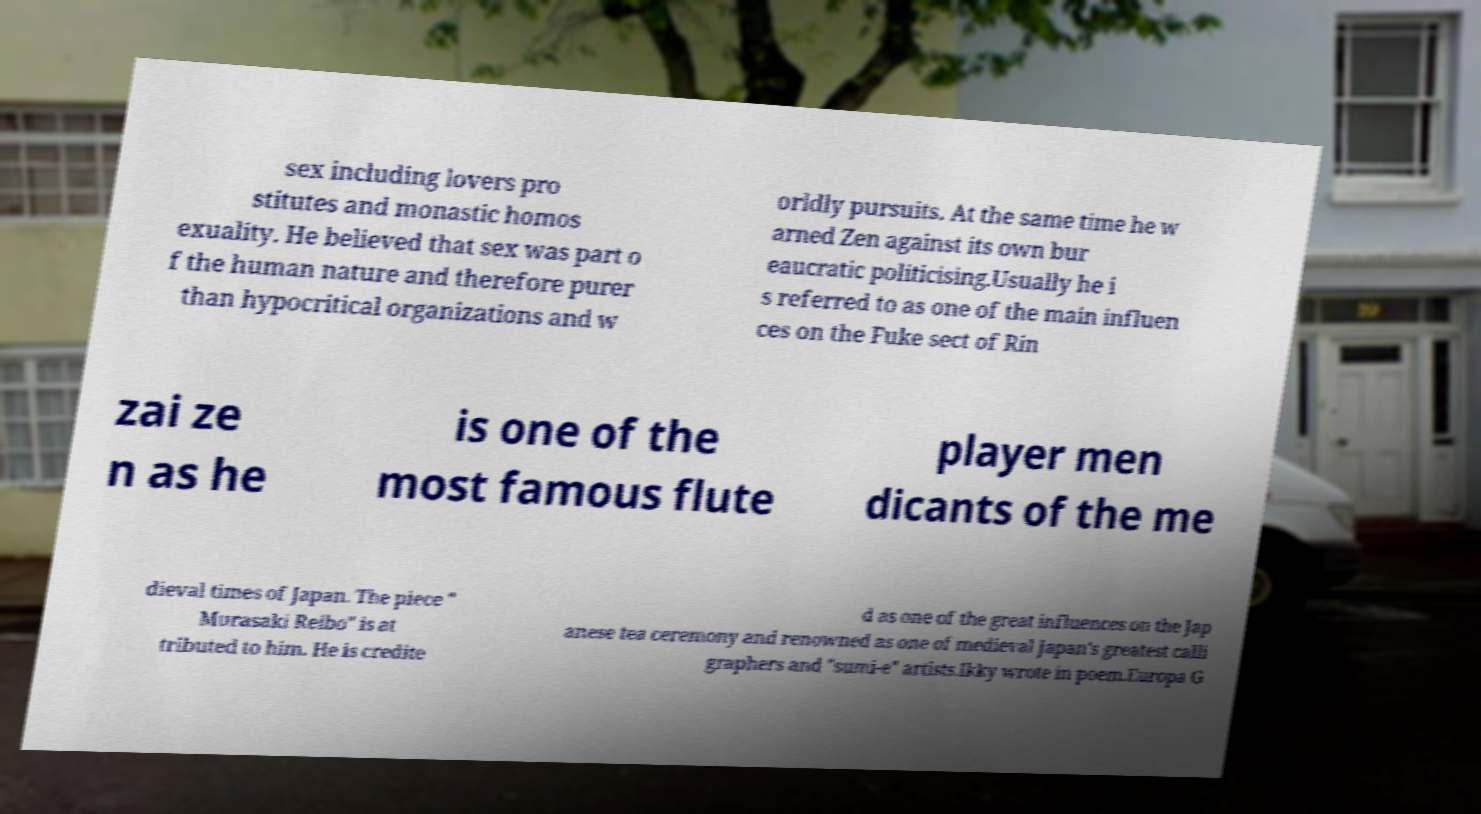There's text embedded in this image that I need extracted. Can you transcribe it verbatim? sex including lovers pro stitutes and monastic homos exuality. He believed that sex was part o f the human nature and therefore purer than hypocritical organizations and w orldly pursuits. At the same time he w arned Zen against its own bur eaucratic politicising.Usually he i s referred to as one of the main influen ces on the Fuke sect of Rin zai ze n as he is one of the most famous flute player men dicants of the me dieval times of Japan. The piece " Murasaki Reibo" is at tributed to him. He is credite d as one of the great influences on the Jap anese tea ceremony and renowned as one of medieval Japan's greatest calli graphers and "sumi-e" artists.Ikky wrote in poem.Europa G 